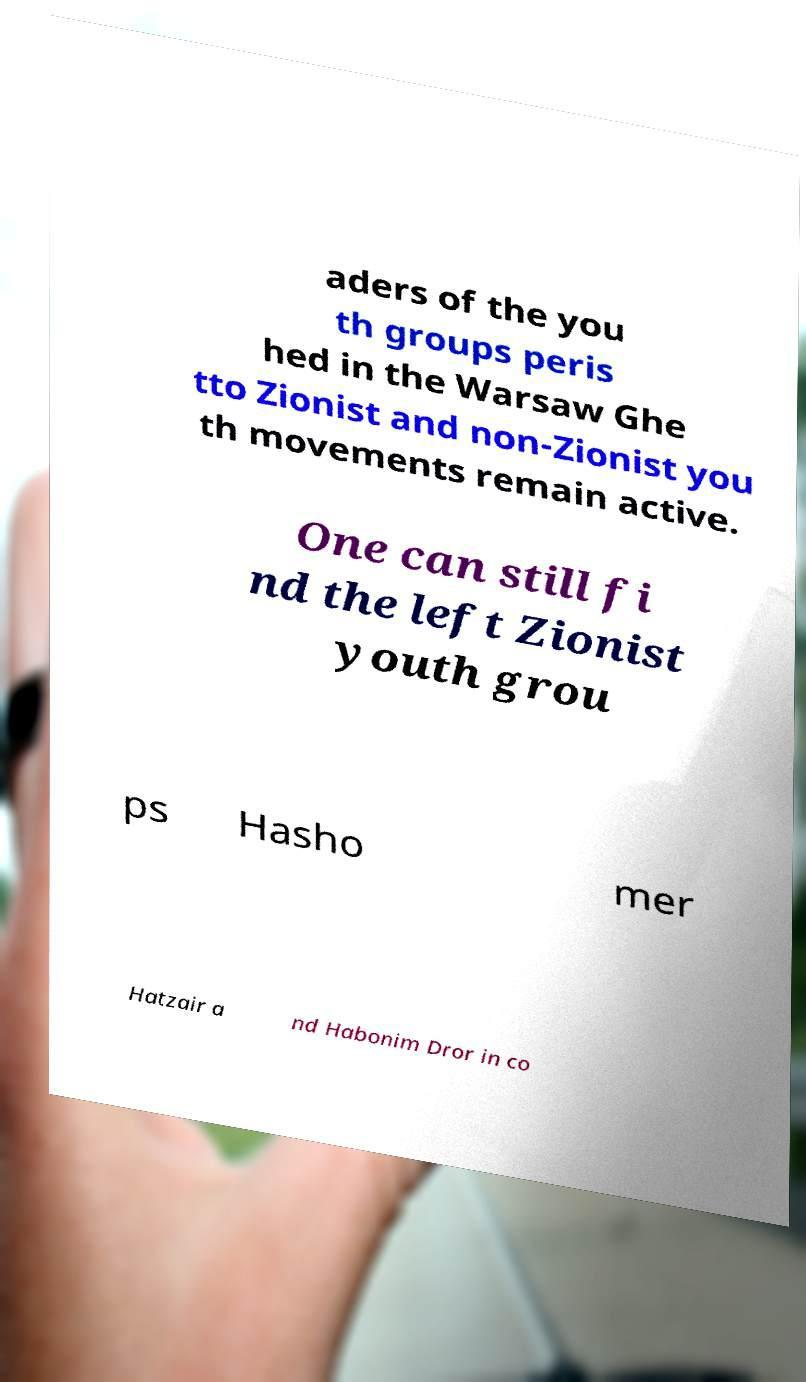What messages or text are displayed in this image? I need them in a readable, typed format. aders of the you th groups peris hed in the Warsaw Ghe tto Zionist and non-Zionist you th movements remain active. One can still fi nd the left Zionist youth grou ps Hasho mer Hatzair a nd Habonim Dror in co 